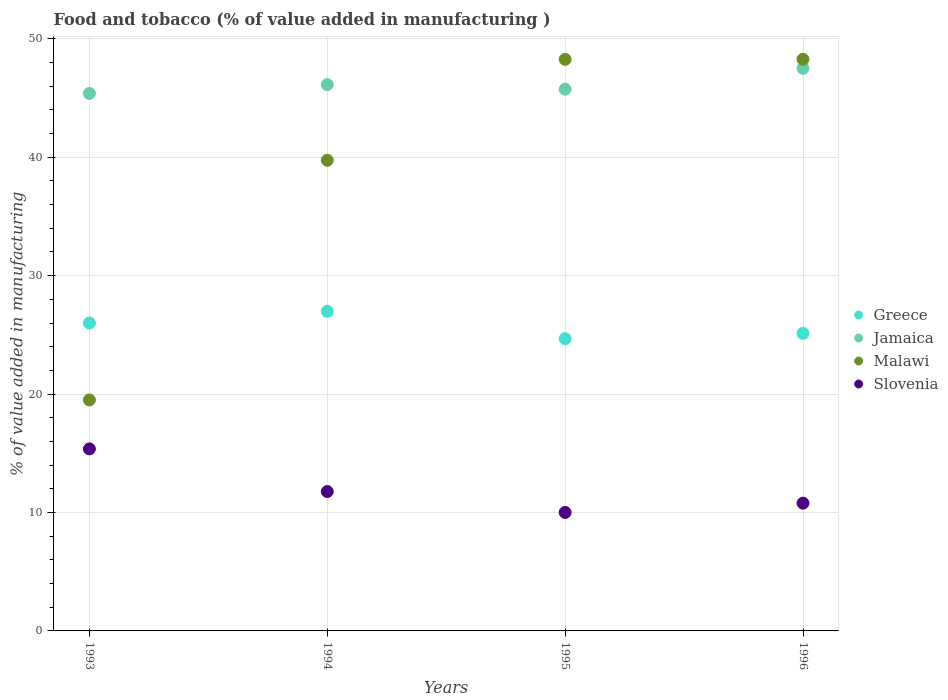How many different coloured dotlines are there?
Offer a terse response. 4. Is the number of dotlines equal to the number of legend labels?
Ensure brevity in your answer.  Yes. What is the value added in manufacturing food and tobacco in Greece in 1996?
Ensure brevity in your answer.  25.13. Across all years, what is the maximum value added in manufacturing food and tobacco in Greece?
Make the answer very short. 26.98. Across all years, what is the minimum value added in manufacturing food and tobacco in Malawi?
Ensure brevity in your answer.  19.5. In which year was the value added in manufacturing food and tobacco in Jamaica maximum?
Provide a short and direct response. 1996. What is the total value added in manufacturing food and tobacco in Malawi in the graph?
Provide a succinct answer. 155.78. What is the difference between the value added in manufacturing food and tobacco in Slovenia in 1995 and that in 1996?
Your answer should be very brief. -0.79. What is the difference between the value added in manufacturing food and tobacco in Greece in 1994 and the value added in manufacturing food and tobacco in Slovenia in 1995?
Your response must be concise. 16.98. What is the average value added in manufacturing food and tobacco in Slovenia per year?
Your answer should be compact. 11.98. In the year 1995, what is the difference between the value added in manufacturing food and tobacco in Slovenia and value added in manufacturing food and tobacco in Jamaica?
Provide a succinct answer. -35.74. What is the ratio of the value added in manufacturing food and tobacco in Malawi in 1993 to that in 1996?
Provide a short and direct response. 0.4. Is the value added in manufacturing food and tobacco in Slovenia in 1994 less than that in 1996?
Your answer should be very brief. No. Is the difference between the value added in manufacturing food and tobacco in Slovenia in 1993 and 1996 greater than the difference between the value added in manufacturing food and tobacco in Jamaica in 1993 and 1996?
Your response must be concise. Yes. What is the difference between the highest and the second highest value added in manufacturing food and tobacco in Jamaica?
Keep it short and to the point. 1.38. What is the difference between the highest and the lowest value added in manufacturing food and tobacco in Greece?
Keep it short and to the point. 2.31. In how many years, is the value added in manufacturing food and tobacco in Greece greater than the average value added in manufacturing food and tobacco in Greece taken over all years?
Offer a terse response. 2. Is it the case that in every year, the sum of the value added in manufacturing food and tobacco in Jamaica and value added in manufacturing food and tobacco in Greece  is greater than the value added in manufacturing food and tobacco in Malawi?
Your response must be concise. Yes. Does the value added in manufacturing food and tobacco in Slovenia monotonically increase over the years?
Offer a terse response. No. Is the value added in manufacturing food and tobacco in Slovenia strictly less than the value added in manufacturing food and tobacco in Greece over the years?
Your answer should be compact. Yes. Where does the legend appear in the graph?
Your answer should be very brief. Center right. How many legend labels are there?
Keep it short and to the point. 4. What is the title of the graph?
Offer a terse response. Food and tobacco (% of value added in manufacturing ). What is the label or title of the Y-axis?
Keep it short and to the point. % of value added in manufacturing. What is the % of value added in manufacturing in Greece in 1993?
Offer a very short reply. 26. What is the % of value added in manufacturing of Jamaica in 1993?
Your response must be concise. 45.38. What is the % of value added in manufacturing in Malawi in 1993?
Provide a short and direct response. 19.5. What is the % of value added in manufacturing of Slovenia in 1993?
Make the answer very short. 15.37. What is the % of value added in manufacturing in Greece in 1994?
Your response must be concise. 26.98. What is the % of value added in manufacturing of Jamaica in 1994?
Provide a succinct answer. 46.13. What is the % of value added in manufacturing in Malawi in 1994?
Offer a very short reply. 39.74. What is the % of value added in manufacturing in Slovenia in 1994?
Your response must be concise. 11.77. What is the % of value added in manufacturing in Greece in 1995?
Provide a succinct answer. 24.68. What is the % of value added in manufacturing of Jamaica in 1995?
Your answer should be very brief. 45.75. What is the % of value added in manufacturing of Malawi in 1995?
Keep it short and to the point. 48.26. What is the % of value added in manufacturing in Slovenia in 1995?
Offer a very short reply. 10. What is the % of value added in manufacturing of Greece in 1996?
Your response must be concise. 25.13. What is the % of value added in manufacturing in Jamaica in 1996?
Offer a terse response. 47.51. What is the % of value added in manufacturing of Malawi in 1996?
Offer a terse response. 48.27. What is the % of value added in manufacturing in Slovenia in 1996?
Make the answer very short. 10.79. Across all years, what is the maximum % of value added in manufacturing in Greece?
Offer a terse response. 26.98. Across all years, what is the maximum % of value added in manufacturing of Jamaica?
Make the answer very short. 47.51. Across all years, what is the maximum % of value added in manufacturing of Malawi?
Provide a short and direct response. 48.27. Across all years, what is the maximum % of value added in manufacturing of Slovenia?
Your answer should be very brief. 15.37. Across all years, what is the minimum % of value added in manufacturing of Greece?
Provide a short and direct response. 24.68. Across all years, what is the minimum % of value added in manufacturing in Jamaica?
Keep it short and to the point. 45.38. Across all years, what is the minimum % of value added in manufacturing in Malawi?
Offer a terse response. 19.5. Across all years, what is the minimum % of value added in manufacturing in Slovenia?
Offer a very short reply. 10. What is the total % of value added in manufacturing in Greece in the graph?
Offer a terse response. 102.79. What is the total % of value added in manufacturing in Jamaica in the graph?
Your response must be concise. 184.77. What is the total % of value added in manufacturing of Malawi in the graph?
Your answer should be very brief. 155.78. What is the total % of value added in manufacturing of Slovenia in the graph?
Your answer should be compact. 47.93. What is the difference between the % of value added in manufacturing of Greece in 1993 and that in 1994?
Your answer should be very brief. -0.98. What is the difference between the % of value added in manufacturing in Jamaica in 1993 and that in 1994?
Give a very brief answer. -0.75. What is the difference between the % of value added in manufacturing of Malawi in 1993 and that in 1994?
Your answer should be compact. -20.24. What is the difference between the % of value added in manufacturing of Slovenia in 1993 and that in 1994?
Your answer should be very brief. 3.6. What is the difference between the % of value added in manufacturing of Greece in 1993 and that in 1995?
Your answer should be very brief. 1.32. What is the difference between the % of value added in manufacturing of Jamaica in 1993 and that in 1995?
Keep it short and to the point. -0.36. What is the difference between the % of value added in manufacturing of Malawi in 1993 and that in 1995?
Keep it short and to the point. -28.76. What is the difference between the % of value added in manufacturing in Slovenia in 1993 and that in 1995?
Provide a succinct answer. 5.37. What is the difference between the % of value added in manufacturing of Greece in 1993 and that in 1996?
Give a very brief answer. 0.88. What is the difference between the % of value added in manufacturing of Jamaica in 1993 and that in 1996?
Provide a succinct answer. -2.12. What is the difference between the % of value added in manufacturing of Malawi in 1993 and that in 1996?
Give a very brief answer. -28.77. What is the difference between the % of value added in manufacturing in Slovenia in 1993 and that in 1996?
Make the answer very short. 4.58. What is the difference between the % of value added in manufacturing in Greece in 1994 and that in 1995?
Make the answer very short. 2.31. What is the difference between the % of value added in manufacturing of Jamaica in 1994 and that in 1995?
Provide a short and direct response. 0.38. What is the difference between the % of value added in manufacturing in Malawi in 1994 and that in 1995?
Offer a terse response. -8.52. What is the difference between the % of value added in manufacturing of Slovenia in 1994 and that in 1995?
Ensure brevity in your answer.  1.77. What is the difference between the % of value added in manufacturing of Greece in 1994 and that in 1996?
Give a very brief answer. 1.86. What is the difference between the % of value added in manufacturing in Jamaica in 1994 and that in 1996?
Provide a succinct answer. -1.38. What is the difference between the % of value added in manufacturing of Malawi in 1994 and that in 1996?
Give a very brief answer. -8.53. What is the difference between the % of value added in manufacturing in Slovenia in 1994 and that in 1996?
Give a very brief answer. 0.98. What is the difference between the % of value added in manufacturing in Greece in 1995 and that in 1996?
Keep it short and to the point. -0.45. What is the difference between the % of value added in manufacturing in Jamaica in 1995 and that in 1996?
Your answer should be compact. -1.76. What is the difference between the % of value added in manufacturing of Malawi in 1995 and that in 1996?
Your answer should be very brief. -0.01. What is the difference between the % of value added in manufacturing of Slovenia in 1995 and that in 1996?
Provide a short and direct response. -0.79. What is the difference between the % of value added in manufacturing in Greece in 1993 and the % of value added in manufacturing in Jamaica in 1994?
Provide a succinct answer. -20.13. What is the difference between the % of value added in manufacturing in Greece in 1993 and the % of value added in manufacturing in Malawi in 1994?
Make the answer very short. -13.74. What is the difference between the % of value added in manufacturing in Greece in 1993 and the % of value added in manufacturing in Slovenia in 1994?
Make the answer very short. 14.23. What is the difference between the % of value added in manufacturing of Jamaica in 1993 and the % of value added in manufacturing of Malawi in 1994?
Give a very brief answer. 5.64. What is the difference between the % of value added in manufacturing of Jamaica in 1993 and the % of value added in manufacturing of Slovenia in 1994?
Provide a succinct answer. 33.61. What is the difference between the % of value added in manufacturing of Malawi in 1993 and the % of value added in manufacturing of Slovenia in 1994?
Offer a terse response. 7.73. What is the difference between the % of value added in manufacturing of Greece in 1993 and the % of value added in manufacturing of Jamaica in 1995?
Give a very brief answer. -19.75. What is the difference between the % of value added in manufacturing of Greece in 1993 and the % of value added in manufacturing of Malawi in 1995?
Provide a short and direct response. -22.26. What is the difference between the % of value added in manufacturing of Greece in 1993 and the % of value added in manufacturing of Slovenia in 1995?
Provide a short and direct response. 16. What is the difference between the % of value added in manufacturing in Jamaica in 1993 and the % of value added in manufacturing in Malawi in 1995?
Your answer should be very brief. -2.88. What is the difference between the % of value added in manufacturing of Jamaica in 1993 and the % of value added in manufacturing of Slovenia in 1995?
Give a very brief answer. 35.38. What is the difference between the % of value added in manufacturing in Malawi in 1993 and the % of value added in manufacturing in Slovenia in 1995?
Keep it short and to the point. 9.5. What is the difference between the % of value added in manufacturing of Greece in 1993 and the % of value added in manufacturing of Jamaica in 1996?
Offer a very short reply. -21.5. What is the difference between the % of value added in manufacturing in Greece in 1993 and the % of value added in manufacturing in Malawi in 1996?
Your answer should be very brief. -22.27. What is the difference between the % of value added in manufacturing in Greece in 1993 and the % of value added in manufacturing in Slovenia in 1996?
Keep it short and to the point. 15.21. What is the difference between the % of value added in manufacturing of Jamaica in 1993 and the % of value added in manufacturing of Malawi in 1996?
Your answer should be compact. -2.89. What is the difference between the % of value added in manufacturing in Jamaica in 1993 and the % of value added in manufacturing in Slovenia in 1996?
Give a very brief answer. 34.59. What is the difference between the % of value added in manufacturing of Malawi in 1993 and the % of value added in manufacturing of Slovenia in 1996?
Your response must be concise. 8.72. What is the difference between the % of value added in manufacturing in Greece in 1994 and the % of value added in manufacturing in Jamaica in 1995?
Your answer should be compact. -18.76. What is the difference between the % of value added in manufacturing of Greece in 1994 and the % of value added in manufacturing of Malawi in 1995?
Give a very brief answer. -21.28. What is the difference between the % of value added in manufacturing in Greece in 1994 and the % of value added in manufacturing in Slovenia in 1995?
Offer a very short reply. 16.98. What is the difference between the % of value added in manufacturing in Jamaica in 1994 and the % of value added in manufacturing in Malawi in 1995?
Provide a succinct answer. -2.13. What is the difference between the % of value added in manufacturing in Jamaica in 1994 and the % of value added in manufacturing in Slovenia in 1995?
Your answer should be compact. 36.13. What is the difference between the % of value added in manufacturing in Malawi in 1994 and the % of value added in manufacturing in Slovenia in 1995?
Your answer should be compact. 29.74. What is the difference between the % of value added in manufacturing of Greece in 1994 and the % of value added in manufacturing of Jamaica in 1996?
Provide a succinct answer. -20.52. What is the difference between the % of value added in manufacturing in Greece in 1994 and the % of value added in manufacturing in Malawi in 1996?
Make the answer very short. -21.29. What is the difference between the % of value added in manufacturing of Greece in 1994 and the % of value added in manufacturing of Slovenia in 1996?
Your answer should be very brief. 16.2. What is the difference between the % of value added in manufacturing in Jamaica in 1994 and the % of value added in manufacturing in Malawi in 1996?
Ensure brevity in your answer.  -2.14. What is the difference between the % of value added in manufacturing in Jamaica in 1994 and the % of value added in manufacturing in Slovenia in 1996?
Offer a very short reply. 35.34. What is the difference between the % of value added in manufacturing in Malawi in 1994 and the % of value added in manufacturing in Slovenia in 1996?
Provide a succinct answer. 28.95. What is the difference between the % of value added in manufacturing of Greece in 1995 and the % of value added in manufacturing of Jamaica in 1996?
Ensure brevity in your answer.  -22.83. What is the difference between the % of value added in manufacturing of Greece in 1995 and the % of value added in manufacturing of Malawi in 1996?
Provide a succinct answer. -23.6. What is the difference between the % of value added in manufacturing in Greece in 1995 and the % of value added in manufacturing in Slovenia in 1996?
Ensure brevity in your answer.  13.89. What is the difference between the % of value added in manufacturing of Jamaica in 1995 and the % of value added in manufacturing of Malawi in 1996?
Ensure brevity in your answer.  -2.53. What is the difference between the % of value added in manufacturing of Jamaica in 1995 and the % of value added in manufacturing of Slovenia in 1996?
Provide a short and direct response. 34.96. What is the difference between the % of value added in manufacturing in Malawi in 1995 and the % of value added in manufacturing in Slovenia in 1996?
Your answer should be very brief. 37.48. What is the average % of value added in manufacturing of Greece per year?
Give a very brief answer. 25.7. What is the average % of value added in manufacturing of Jamaica per year?
Offer a very short reply. 46.19. What is the average % of value added in manufacturing of Malawi per year?
Your answer should be compact. 38.95. What is the average % of value added in manufacturing in Slovenia per year?
Your answer should be very brief. 11.98. In the year 1993, what is the difference between the % of value added in manufacturing of Greece and % of value added in manufacturing of Jamaica?
Make the answer very short. -19.38. In the year 1993, what is the difference between the % of value added in manufacturing of Greece and % of value added in manufacturing of Malawi?
Your response must be concise. 6.5. In the year 1993, what is the difference between the % of value added in manufacturing of Greece and % of value added in manufacturing of Slovenia?
Make the answer very short. 10.63. In the year 1993, what is the difference between the % of value added in manufacturing in Jamaica and % of value added in manufacturing in Malawi?
Ensure brevity in your answer.  25.88. In the year 1993, what is the difference between the % of value added in manufacturing in Jamaica and % of value added in manufacturing in Slovenia?
Ensure brevity in your answer.  30.01. In the year 1993, what is the difference between the % of value added in manufacturing of Malawi and % of value added in manufacturing of Slovenia?
Offer a terse response. 4.13. In the year 1994, what is the difference between the % of value added in manufacturing in Greece and % of value added in manufacturing in Jamaica?
Offer a very short reply. -19.15. In the year 1994, what is the difference between the % of value added in manufacturing of Greece and % of value added in manufacturing of Malawi?
Your answer should be compact. -12.76. In the year 1994, what is the difference between the % of value added in manufacturing in Greece and % of value added in manufacturing in Slovenia?
Give a very brief answer. 15.21. In the year 1994, what is the difference between the % of value added in manufacturing of Jamaica and % of value added in manufacturing of Malawi?
Provide a succinct answer. 6.39. In the year 1994, what is the difference between the % of value added in manufacturing of Jamaica and % of value added in manufacturing of Slovenia?
Give a very brief answer. 34.36. In the year 1994, what is the difference between the % of value added in manufacturing of Malawi and % of value added in manufacturing of Slovenia?
Keep it short and to the point. 27.97. In the year 1995, what is the difference between the % of value added in manufacturing in Greece and % of value added in manufacturing in Jamaica?
Offer a very short reply. -21.07. In the year 1995, what is the difference between the % of value added in manufacturing of Greece and % of value added in manufacturing of Malawi?
Give a very brief answer. -23.59. In the year 1995, what is the difference between the % of value added in manufacturing of Greece and % of value added in manufacturing of Slovenia?
Your response must be concise. 14.67. In the year 1995, what is the difference between the % of value added in manufacturing of Jamaica and % of value added in manufacturing of Malawi?
Your response must be concise. -2.52. In the year 1995, what is the difference between the % of value added in manufacturing of Jamaica and % of value added in manufacturing of Slovenia?
Keep it short and to the point. 35.74. In the year 1995, what is the difference between the % of value added in manufacturing in Malawi and % of value added in manufacturing in Slovenia?
Provide a short and direct response. 38.26. In the year 1996, what is the difference between the % of value added in manufacturing of Greece and % of value added in manufacturing of Jamaica?
Provide a succinct answer. -22.38. In the year 1996, what is the difference between the % of value added in manufacturing of Greece and % of value added in manufacturing of Malawi?
Make the answer very short. -23.15. In the year 1996, what is the difference between the % of value added in manufacturing of Greece and % of value added in manufacturing of Slovenia?
Your answer should be compact. 14.34. In the year 1996, what is the difference between the % of value added in manufacturing in Jamaica and % of value added in manufacturing in Malawi?
Keep it short and to the point. -0.77. In the year 1996, what is the difference between the % of value added in manufacturing in Jamaica and % of value added in manufacturing in Slovenia?
Ensure brevity in your answer.  36.72. In the year 1996, what is the difference between the % of value added in manufacturing in Malawi and % of value added in manufacturing in Slovenia?
Offer a very short reply. 37.49. What is the ratio of the % of value added in manufacturing in Greece in 1993 to that in 1994?
Provide a succinct answer. 0.96. What is the ratio of the % of value added in manufacturing in Jamaica in 1993 to that in 1994?
Provide a short and direct response. 0.98. What is the ratio of the % of value added in manufacturing of Malawi in 1993 to that in 1994?
Ensure brevity in your answer.  0.49. What is the ratio of the % of value added in manufacturing of Slovenia in 1993 to that in 1994?
Give a very brief answer. 1.31. What is the ratio of the % of value added in manufacturing in Greece in 1993 to that in 1995?
Ensure brevity in your answer.  1.05. What is the ratio of the % of value added in manufacturing of Jamaica in 1993 to that in 1995?
Give a very brief answer. 0.99. What is the ratio of the % of value added in manufacturing in Malawi in 1993 to that in 1995?
Make the answer very short. 0.4. What is the ratio of the % of value added in manufacturing in Slovenia in 1993 to that in 1995?
Your response must be concise. 1.54. What is the ratio of the % of value added in manufacturing of Greece in 1993 to that in 1996?
Keep it short and to the point. 1.03. What is the ratio of the % of value added in manufacturing in Jamaica in 1993 to that in 1996?
Offer a terse response. 0.96. What is the ratio of the % of value added in manufacturing of Malawi in 1993 to that in 1996?
Ensure brevity in your answer.  0.4. What is the ratio of the % of value added in manufacturing of Slovenia in 1993 to that in 1996?
Provide a short and direct response. 1.42. What is the ratio of the % of value added in manufacturing in Greece in 1994 to that in 1995?
Provide a succinct answer. 1.09. What is the ratio of the % of value added in manufacturing in Jamaica in 1994 to that in 1995?
Offer a very short reply. 1.01. What is the ratio of the % of value added in manufacturing in Malawi in 1994 to that in 1995?
Give a very brief answer. 0.82. What is the ratio of the % of value added in manufacturing of Slovenia in 1994 to that in 1995?
Ensure brevity in your answer.  1.18. What is the ratio of the % of value added in manufacturing of Greece in 1994 to that in 1996?
Give a very brief answer. 1.07. What is the ratio of the % of value added in manufacturing of Jamaica in 1994 to that in 1996?
Provide a succinct answer. 0.97. What is the ratio of the % of value added in manufacturing in Malawi in 1994 to that in 1996?
Offer a terse response. 0.82. What is the ratio of the % of value added in manufacturing in Slovenia in 1994 to that in 1996?
Your answer should be very brief. 1.09. What is the ratio of the % of value added in manufacturing in Greece in 1995 to that in 1996?
Provide a succinct answer. 0.98. What is the ratio of the % of value added in manufacturing of Slovenia in 1995 to that in 1996?
Make the answer very short. 0.93. What is the difference between the highest and the second highest % of value added in manufacturing of Greece?
Give a very brief answer. 0.98. What is the difference between the highest and the second highest % of value added in manufacturing of Jamaica?
Provide a short and direct response. 1.38. What is the difference between the highest and the second highest % of value added in manufacturing in Malawi?
Provide a short and direct response. 0.01. What is the difference between the highest and the second highest % of value added in manufacturing of Slovenia?
Provide a succinct answer. 3.6. What is the difference between the highest and the lowest % of value added in manufacturing in Greece?
Keep it short and to the point. 2.31. What is the difference between the highest and the lowest % of value added in manufacturing of Jamaica?
Give a very brief answer. 2.12. What is the difference between the highest and the lowest % of value added in manufacturing of Malawi?
Provide a succinct answer. 28.77. What is the difference between the highest and the lowest % of value added in manufacturing in Slovenia?
Keep it short and to the point. 5.37. 